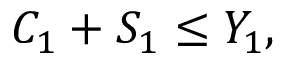Convert formula to latex. <formula><loc_0><loc_0><loc_500><loc_500>C _ { 1 } + S _ { 1 } \leq Y _ { 1 } ,</formula> 